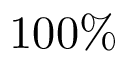Convert formula to latex. <formula><loc_0><loc_0><loc_500><loc_500>1 0 0 \%</formula> 